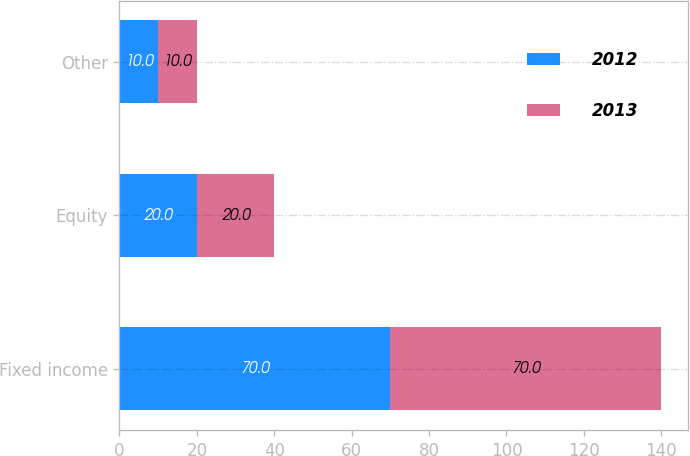Convert chart to OTSL. <chart><loc_0><loc_0><loc_500><loc_500><stacked_bar_chart><ecel><fcel>Fixed income<fcel>Equity<fcel>Other<nl><fcel>2012<fcel>70<fcel>20<fcel>10<nl><fcel>2013<fcel>70<fcel>20<fcel>10<nl></chart> 